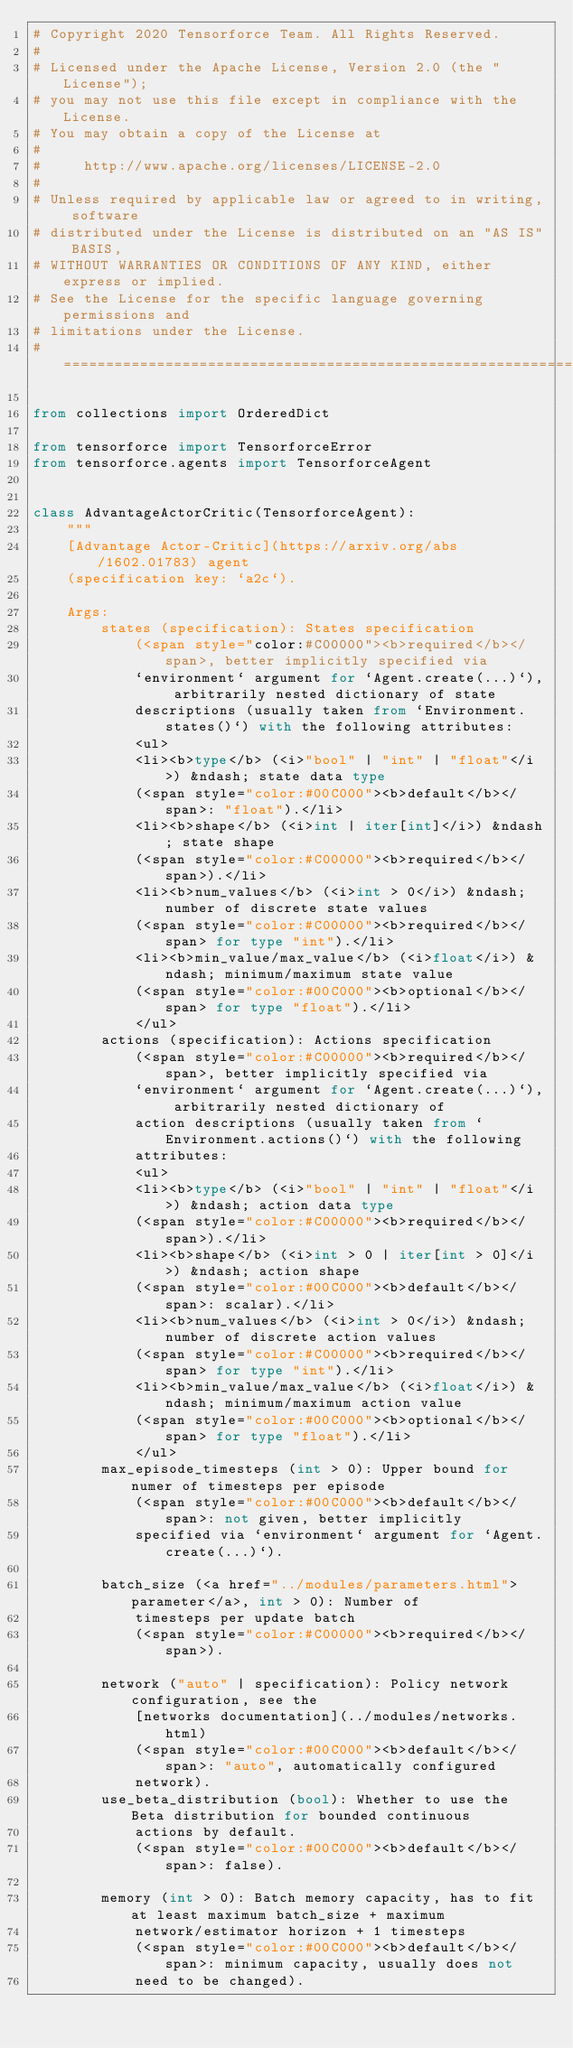<code> <loc_0><loc_0><loc_500><loc_500><_Python_># Copyright 2020 Tensorforce Team. All Rights Reserved.
#
# Licensed under the Apache License, Version 2.0 (the "License");
# you may not use this file except in compliance with the License.
# You may obtain a copy of the License at
#
#     http://www.apache.org/licenses/LICENSE-2.0
#
# Unless required by applicable law or agreed to in writing, software
# distributed under the License is distributed on an "AS IS" BASIS,
# WITHOUT WARRANTIES OR CONDITIONS OF ANY KIND, either express or implied.
# See the License for the specific language governing permissions and
# limitations under the License.
# ==============================================================================

from collections import OrderedDict

from tensorforce import TensorforceError
from tensorforce.agents import TensorforceAgent


class AdvantageActorCritic(TensorforceAgent):
    """
    [Advantage Actor-Critic](https://arxiv.org/abs/1602.01783) agent
    (specification key: `a2c`).

    Args:
        states (specification): States specification
            (<span style="color:#C00000"><b>required</b></span>, better implicitly specified via
            `environment` argument for `Agent.create(...)`), arbitrarily nested dictionary of state
            descriptions (usually taken from `Environment.states()`) with the following attributes:
            <ul>
            <li><b>type</b> (<i>"bool" | "int" | "float"</i>) &ndash; state data type
            (<span style="color:#00C000"><b>default</b></span>: "float").</li>
            <li><b>shape</b> (<i>int | iter[int]</i>) &ndash; state shape
            (<span style="color:#C00000"><b>required</b></span>).</li>
            <li><b>num_values</b> (<i>int > 0</i>) &ndash; number of discrete state values
            (<span style="color:#C00000"><b>required</b></span> for type "int").</li>
            <li><b>min_value/max_value</b> (<i>float</i>) &ndash; minimum/maximum state value
            (<span style="color:#00C000"><b>optional</b></span> for type "float").</li>
            </ul>
        actions (specification): Actions specification
            (<span style="color:#C00000"><b>required</b></span>, better implicitly specified via
            `environment` argument for `Agent.create(...)`), arbitrarily nested dictionary of
            action descriptions (usually taken from `Environment.actions()`) with the following
            attributes:
            <ul>
            <li><b>type</b> (<i>"bool" | "int" | "float"</i>) &ndash; action data type
            (<span style="color:#C00000"><b>required</b></span>).</li>
            <li><b>shape</b> (<i>int > 0 | iter[int > 0]</i>) &ndash; action shape
            (<span style="color:#00C000"><b>default</b></span>: scalar).</li>
            <li><b>num_values</b> (<i>int > 0</i>) &ndash; number of discrete action values
            (<span style="color:#C00000"><b>required</b></span> for type "int").</li>
            <li><b>min_value/max_value</b> (<i>float</i>) &ndash; minimum/maximum action value
            (<span style="color:#00C000"><b>optional</b></span> for type "float").</li>
            </ul>
        max_episode_timesteps (int > 0): Upper bound for numer of timesteps per episode
            (<span style="color:#00C000"><b>default</b></span>: not given, better implicitly
            specified via `environment` argument for `Agent.create(...)`).

        batch_size (<a href="../modules/parameters.html">parameter</a>, int > 0): Number of
            timesteps per update batch
            (<span style="color:#C00000"><b>required</b></span>).

        network ("auto" | specification): Policy network configuration, see the
            [networks documentation](../modules/networks.html)
            (<span style="color:#00C000"><b>default</b></span>: "auto", automatically configured
            network).
        use_beta_distribution (bool): Whether to use the Beta distribution for bounded continuous
            actions by default.
            (<span style="color:#00C000"><b>default</b></span>: false).

        memory (int > 0): Batch memory capacity, has to fit at least maximum batch_size + maximum
            network/estimator horizon + 1 timesteps
            (<span style="color:#00C000"><b>default</b></span>: minimum capacity, usually does not
            need to be changed).</code> 